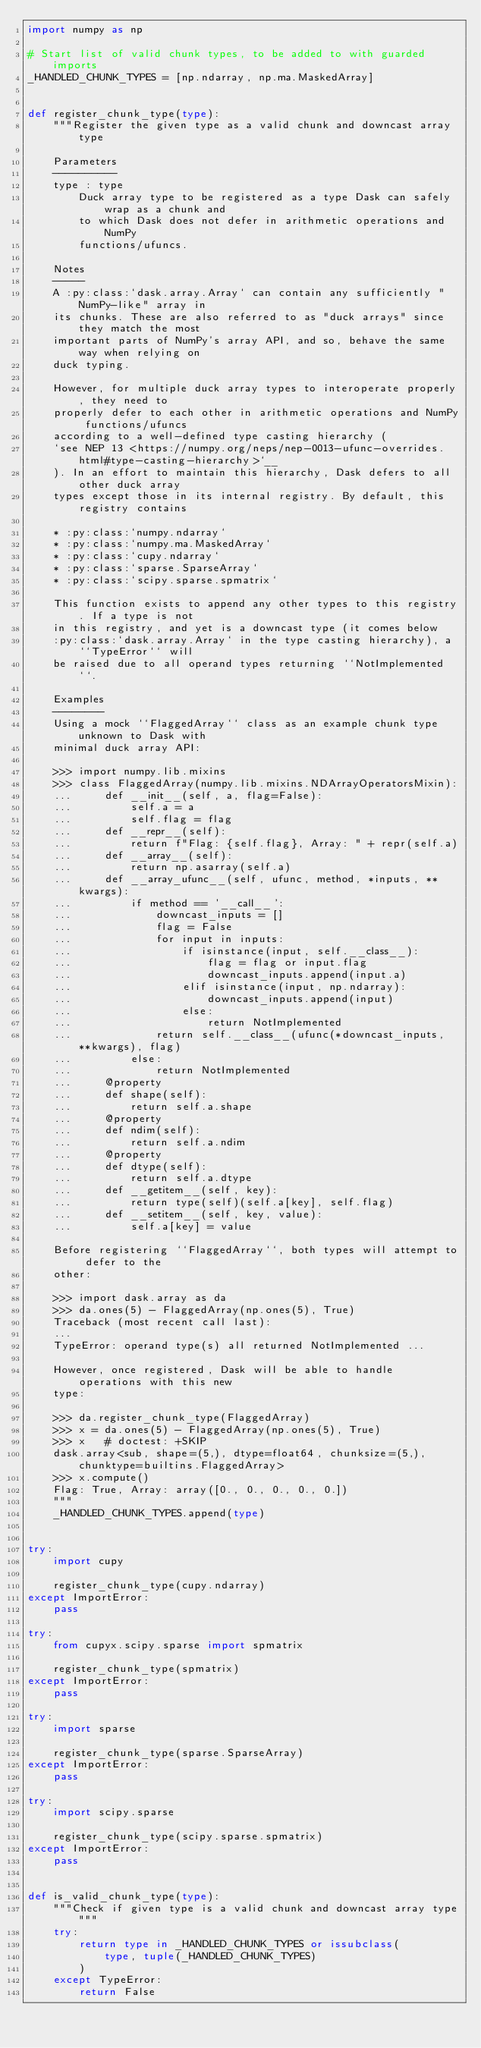Convert code to text. <code><loc_0><loc_0><loc_500><loc_500><_Python_>import numpy as np

# Start list of valid chunk types, to be added to with guarded imports
_HANDLED_CHUNK_TYPES = [np.ndarray, np.ma.MaskedArray]


def register_chunk_type(type):
    """Register the given type as a valid chunk and downcast array type

    Parameters
    ----------
    type : type
        Duck array type to be registered as a type Dask can safely wrap as a chunk and
        to which Dask does not defer in arithmetic operations and NumPy
        functions/ufuncs.

    Notes
    -----
    A :py:class:`dask.array.Array` can contain any sufficiently "NumPy-like" array in
    its chunks. These are also referred to as "duck arrays" since they match the most
    important parts of NumPy's array API, and so, behave the same way when relying on
    duck typing.

    However, for multiple duck array types to interoperate properly, they need to
    properly defer to each other in arithmetic operations and NumPy functions/ufuncs
    according to a well-defined type casting hierarchy (
    `see NEP 13 <https://numpy.org/neps/nep-0013-ufunc-overrides.html#type-casting-hierarchy>`__
    ). In an effort to maintain this hierarchy, Dask defers to all other duck array
    types except those in its internal registry. By default, this registry contains

    * :py:class:`numpy.ndarray`
    * :py:class:`numpy.ma.MaskedArray`
    * :py:class:`cupy.ndarray`
    * :py:class:`sparse.SparseArray`
    * :py:class:`scipy.sparse.spmatrix`

    This function exists to append any other types to this registry. If a type is not
    in this registry, and yet is a downcast type (it comes below
    :py:class:`dask.array.Array` in the type casting hierarchy), a ``TypeError`` will
    be raised due to all operand types returning ``NotImplemented``.

    Examples
    --------
    Using a mock ``FlaggedArray`` class as an example chunk type unknown to Dask with
    minimal duck array API:

    >>> import numpy.lib.mixins
    >>> class FlaggedArray(numpy.lib.mixins.NDArrayOperatorsMixin):
    ...     def __init__(self, a, flag=False):
    ...         self.a = a
    ...         self.flag = flag
    ...     def __repr__(self):
    ...         return f"Flag: {self.flag}, Array: " + repr(self.a)
    ...     def __array__(self):
    ...         return np.asarray(self.a)
    ...     def __array_ufunc__(self, ufunc, method, *inputs, **kwargs):
    ...         if method == '__call__':
    ...             downcast_inputs = []
    ...             flag = False
    ...             for input in inputs:
    ...                 if isinstance(input, self.__class__):
    ...                     flag = flag or input.flag
    ...                     downcast_inputs.append(input.a)
    ...                 elif isinstance(input, np.ndarray):
    ...                     downcast_inputs.append(input)
    ...                 else:
    ...                     return NotImplemented
    ...             return self.__class__(ufunc(*downcast_inputs, **kwargs), flag)
    ...         else:
    ...             return NotImplemented
    ...     @property
    ...     def shape(self):
    ...         return self.a.shape
    ...     @property
    ...     def ndim(self):
    ...         return self.a.ndim
    ...     @property
    ...     def dtype(self):
    ...         return self.a.dtype
    ...     def __getitem__(self, key):
    ...         return type(self)(self.a[key], self.flag)
    ...     def __setitem__(self, key, value):
    ...         self.a[key] = value

    Before registering ``FlaggedArray``, both types will attempt to defer to the
    other:

    >>> import dask.array as da
    >>> da.ones(5) - FlaggedArray(np.ones(5), True)
    Traceback (most recent call last):
    ...
    TypeError: operand type(s) all returned NotImplemented ...

    However, once registered, Dask will be able to handle operations with this new
    type:

    >>> da.register_chunk_type(FlaggedArray)
    >>> x = da.ones(5) - FlaggedArray(np.ones(5), True)
    >>> x   # doctest: +SKIP
    dask.array<sub, shape=(5,), dtype=float64, chunksize=(5,), chunktype=builtins.FlaggedArray>
    >>> x.compute()
    Flag: True, Array: array([0., 0., 0., 0., 0.])
    """
    _HANDLED_CHUNK_TYPES.append(type)


try:
    import cupy

    register_chunk_type(cupy.ndarray)
except ImportError:
    pass

try:
    from cupyx.scipy.sparse import spmatrix

    register_chunk_type(spmatrix)
except ImportError:
    pass

try:
    import sparse

    register_chunk_type(sparse.SparseArray)
except ImportError:
    pass

try:
    import scipy.sparse

    register_chunk_type(scipy.sparse.spmatrix)
except ImportError:
    pass


def is_valid_chunk_type(type):
    """Check if given type is a valid chunk and downcast array type"""
    try:
        return type in _HANDLED_CHUNK_TYPES or issubclass(
            type, tuple(_HANDLED_CHUNK_TYPES)
        )
    except TypeError:
        return False

</code> 